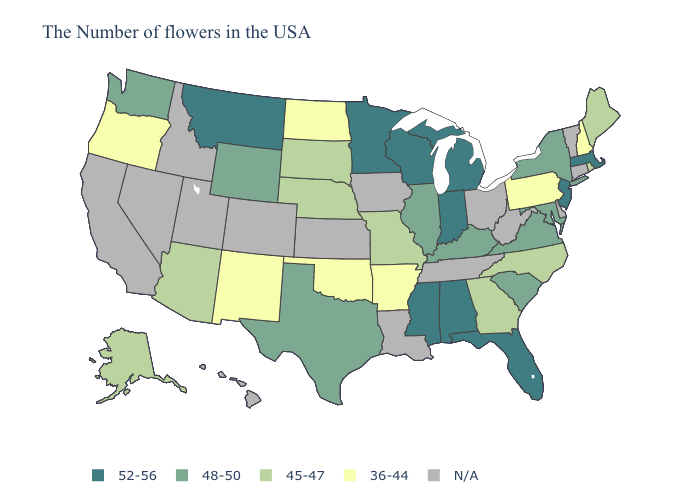Name the states that have a value in the range 52-56?
Write a very short answer. Massachusetts, New Jersey, Florida, Michigan, Indiana, Alabama, Wisconsin, Mississippi, Minnesota, Montana. Name the states that have a value in the range 48-50?
Be succinct. New York, Maryland, Virginia, South Carolina, Kentucky, Illinois, Texas, Wyoming, Washington. What is the lowest value in states that border South Carolina?
Concise answer only. 45-47. Does the map have missing data?
Answer briefly. Yes. Which states have the highest value in the USA?
Answer briefly. Massachusetts, New Jersey, Florida, Michigan, Indiana, Alabama, Wisconsin, Mississippi, Minnesota, Montana. Does Arkansas have the lowest value in the South?
Quick response, please. Yes. Does North Dakota have the lowest value in the USA?
Answer briefly. Yes. Name the states that have a value in the range 52-56?
Answer briefly. Massachusetts, New Jersey, Florida, Michigan, Indiana, Alabama, Wisconsin, Mississippi, Minnesota, Montana. What is the value of Maine?
Give a very brief answer. 45-47. What is the highest value in the Northeast ?
Give a very brief answer. 52-56. Does Oklahoma have the lowest value in the South?
Be succinct. Yes. Name the states that have a value in the range N/A?
Give a very brief answer. Vermont, Connecticut, Delaware, West Virginia, Ohio, Tennessee, Louisiana, Iowa, Kansas, Colorado, Utah, Idaho, Nevada, California, Hawaii. Among the states that border New Hampshire , does Maine have the lowest value?
Be succinct. Yes. What is the value of North Carolina?
Concise answer only. 45-47. 